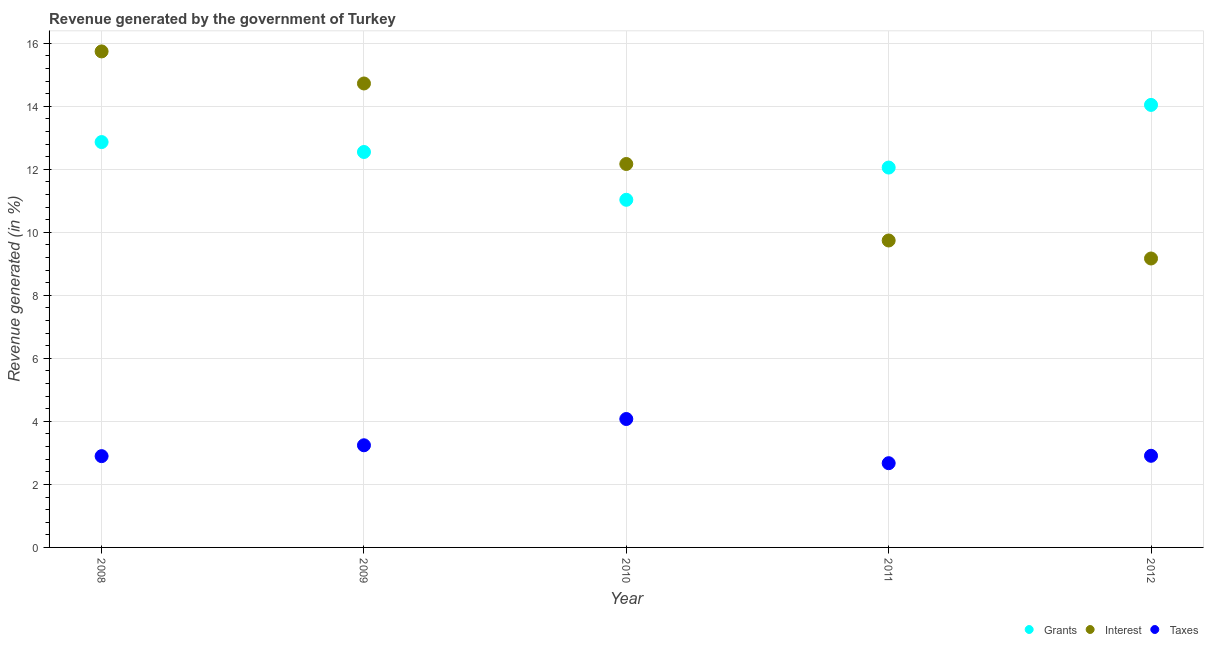How many different coloured dotlines are there?
Your response must be concise. 3. What is the percentage of revenue generated by grants in 2008?
Offer a terse response. 12.86. Across all years, what is the maximum percentage of revenue generated by grants?
Your response must be concise. 14.04. Across all years, what is the minimum percentage of revenue generated by interest?
Your answer should be compact. 9.17. In which year was the percentage of revenue generated by grants maximum?
Provide a succinct answer. 2012. What is the total percentage of revenue generated by taxes in the graph?
Provide a short and direct response. 15.8. What is the difference between the percentage of revenue generated by grants in 2008 and that in 2010?
Offer a very short reply. 1.83. What is the difference between the percentage of revenue generated by taxes in 2010 and the percentage of revenue generated by grants in 2012?
Ensure brevity in your answer.  -9.97. What is the average percentage of revenue generated by grants per year?
Make the answer very short. 12.51. In the year 2008, what is the difference between the percentage of revenue generated by interest and percentage of revenue generated by grants?
Provide a short and direct response. 2.88. What is the ratio of the percentage of revenue generated by taxes in 2009 to that in 2010?
Your answer should be compact. 0.8. What is the difference between the highest and the second highest percentage of revenue generated by taxes?
Give a very brief answer. 0.83. What is the difference between the highest and the lowest percentage of revenue generated by interest?
Your answer should be very brief. 6.57. Is the sum of the percentage of revenue generated by taxes in 2009 and 2011 greater than the maximum percentage of revenue generated by grants across all years?
Give a very brief answer. No. Is it the case that in every year, the sum of the percentage of revenue generated by grants and percentage of revenue generated by interest is greater than the percentage of revenue generated by taxes?
Provide a succinct answer. Yes. Is the percentage of revenue generated by grants strictly less than the percentage of revenue generated by taxes over the years?
Offer a terse response. No. How many years are there in the graph?
Make the answer very short. 5. What is the difference between two consecutive major ticks on the Y-axis?
Provide a short and direct response. 2. Does the graph contain grids?
Offer a terse response. Yes. Where does the legend appear in the graph?
Your answer should be very brief. Bottom right. What is the title of the graph?
Your answer should be very brief. Revenue generated by the government of Turkey. What is the label or title of the Y-axis?
Make the answer very short. Revenue generated (in %). What is the Revenue generated (in %) in Grants in 2008?
Provide a short and direct response. 12.86. What is the Revenue generated (in %) in Interest in 2008?
Your response must be concise. 15.74. What is the Revenue generated (in %) in Taxes in 2008?
Your response must be concise. 2.9. What is the Revenue generated (in %) in Grants in 2009?
Ensure brevity in your answer.  12.55. What is the Revenue generated (in %) in Interest in 2009?
Ensure brevity in your answer.  14.72. What is the Revenue generated (in %) of Taxes in 2009?
Offer a very short reply. 3.24. What is the Revenue generated (in %) in Grants in 2010?
Your answer should be very brief. 11.03. What is the Revenue generated (in %) in Interest in 2010?
Your answer should be very brief. 12.17. What is the Revenue generated (in %) in Taxes in 2010?
Offer a very short reply. 4.08. What is the Revenue generated (in %) in Grants in 2011?
Your answer should be very brief. 12.05. What is the Revenue generated (in %) in Interest in 2011?
Offer a terse response. 9.74. What is the Revenue generated (in %) in Taxes in 2011?
Offer a very short reply. 2.67. What is the Revenue generated (in %) in Grants in 2012?
Provide a succinct answer. 14.04. What is the Revenue generated (in %) of Interest in 2012?
Make the answer very short. 9.17. What is the Revenue generated (in %) of Taxes in 2012?
Keep it short and to the point. 2.91. Across all years, what is the maximum Revenue generated (in %) in Grants?
Make the answer very short. 14.04. Across all years, what is the maximum Revenue generated (in %) of Interest?
Your answer should be compact. 15.74. Across all years, what is the maximum Revenue generated (in %) of Taxes?
Provide a succinct answer. 4.08. Across all years, what is the minimum Revenue generated (in %) in Grants?
Keep it short and to the point. 11.03. Across all years, what is the minimum Revenue generated (in %) in Interest?
Your response must be concise. 9.17. Across all years, what is the minimum Revenue generated (in %) in Taxes?
Offer a terse response. 2.67. What is the total Revenue generated (in %) in Grants in the graph?
Keep it short and to the point. 62.54. What is the total Revenue generated (in %) of Interest in the graph?
Keep it short and to the point. 61.54. What is the total Revenue generated (in %) in Taxes in the graph?
Offer a terse response. 15.8. What is the difference between the Revenue generated (in %) of Grants in 2008 and that in 2009?
Your answer should be very brief. 0.32. What is the difference between the Revenue generated (in %) of Interest in 2008 and that in 2009?
Keep it short and to the point. 1.02. What is the difference between the Revenue generated (in %) in Taxes in 2008 and that in 2009?
Provide a succinct answer. -0.34. What is the difference between the Revenue generated (in %) of Grants in 2008 and that in 2010?
Offer a very short reply. 1.83. What is the difference between the Revenue generated (in %) in Interest in 2008 and that in 2010?
Offer a terse response. 3.57. What is the difference between the Revenue generated (in %) in Taxes in 2008 and that in 2010?
Make the answer very short. -1.18. What is the difference between the Revenue generated (in %) of Grants in 2008 and that in 2011?
Your response must be concise. 0.81. What is the difference between the Revenue generated (in %) in Interest in 2008 and that in 2011?
Provide a short and direct response. 6. What is the difference between the Revenue generated (in %) in Taxes in 2008 and that in 2011?
Your answer should be compact. 0.22. What is the difference between the Revenue generated (in %) of Grants in 2008 and that in 2012?
Keep it short and to the point. -1.18. What is the difference between the Revenue generated (in %) in Interest in 2008 and that in 2012?
Make the answer very short. 6.57. What is the difference between the Revenue generated (in %) in Taxes in 2008 and that in 2012?
Your response must be concise. -0.01. What is the difference between the Revenue generated (in %) in Grants in 2009 and that in 2010?
Your answer should be very brief. 1.52. What is the difference between the Revenue generated (in %) in Interest in 2009 and that in 2010?
Give a very brief answer. 2.56. What is the difference between the Revenue generated (in %) of Taxes in 2009 and that in 2010?
Offer a terse response. -0.83. What is the difference between the Revenue generated (in %) in Grants in 2009 and that in 2011?
Ensure brevity in your answer.  0.49. What is the difference between the Revenue generated (in %) in Interest in 2009 and that in 2011?
Your response must be concise. 4.98. What is the difference between the Revenue generated (in %) of Taxes in 2009 and that in 2011?
Provide a short and direct response. 0.57. What is the difference between the Revenue generated (in %) in Grants in 2009 and that in 2012?
Give a very brief answer. -1.49. What is the difference between the Revenue generated (in %) in Interest in 2009 and that in 2012?
Offer a terse response. 5.55. What is the difference between the Revenue generated (in %) of Taxes in 2009 and that in 2012?
Ensure brevity in your answer.  0.33. What is the difference between the Revenue generated (in %) of Grants in 2010 and that in 2011?
Ensure brevity in your answer.  -1.02. What is the difference between the Revenue generated (in %) in Interest in 2010 and that in 2011?
Give a very brief answer. 2.43. What is the difference between the Revenue generated (in %) in Taxes in 2010 and that in 2011?
Make the answer very short. 1.4. What is the difference between the Revenue generated (in %) in Grants in 2010 and that in 2012?
Keep it short and to the point. -3.01. What is the difference between the Revenue generated (in %) of Interest in 2010 and that in 2012?
Offer a terse response. 3. What is the difference between the Revenue generated (in %) in Taxes in 2010 and that in 2012?
Offer a terse response. 1.17. What is the difference between the Revenue generated (in %) of Grants in 2011 and that in 2012?
Your answer should be very brief. -1.99. What is the difference between the Revenue generated (in %) of Interest in 2011 and that in 2012?
Give a very brief answer. 0.57. What is the difference between the Revenue generated (in %) in Taxes in 2011 and that in 2012?
Provide a short and direct response. -0.23. What is the difference between the Revenue generated (in %) of Grants in 2008 and the Revenue generated (in %) of Interest in 2009?
Provide a succinct answer. -1.86. What is the difference between the Revenue generated (in %) of Grants in 2008 and the Revenue generated (in %) of Taxes in 2009?
Your answer should be very brief. 9.62. What is the difference between the Revenue generated (in %) in Interest in 2008 and the Revenue generated (in %) in Taxes in 2009?
Provide a succinct answer. 12.5. What is the difference between the Revenue generated (in %) in Grants in 2008 and the Revenue generated (in %) in Interest in 2010?
Provide a short and direct response. 0.7. What is the difference between the Revenue generated (in %) in Grants in 2008 and the Revenue generated (in %) in Taxes in 2010?
Keep it short and to the point. 8.79. What is the difference between the Revenue generated (in %) in Interest in 2008 and the Revenue generated (in %) in Taxes in 2010?
Provide a short and direct response. 11.67. What is the difference between the Revenue generated (in %) of Grants in 2008 and the Revenue generated (in %) of Interest in 2011?
Provide a succinct answer. 3.12. What is the difference between the Revenue generated (in %) in Grants in 2008 and the Revenue generated (in %) in Taxes in 2011?
Give a very brief answer. 10.19. What is the difference between the Revenue generated (in %) in Interest in 2008 and the Revenue generated (in %) in Taxes in 2011?
Your answer should be compact. 13.07. What is the difference between the Revenue generated (in %) in Grants in 2008 and the Revenue generated (in %) in Interest in 2012?
Provide a short and direct response. 3.69. What is the difference between the Revenue generated (in %) in Grants in 2008 and the Revenue generated (in %) in Taxes in 2012?
Make the answer very short. 9.96. What is the difference between the Revenue generated (in %) in Interest in 2008 and the Revenue generated (in %) in Taxes in 2012?
Your answer should be very brief. 12.83. What is the difference between the Revenue generated (in %) in Grants in 2009 and the Revenue generated (in %) in Interest in 2010?
Offer a very short reply. 0.38. What is the difference between the Revenue generated (in %) in Grants in 2009 and the Revenue generated (in %) in Taxes in 2010?
Offer a terse response. 8.47. What is the difference between the Revenue generated (in %) of Interest in 2009 and the Revenue generated (in %) of Taxes in 2010?
Offer a very short reply. 10.65. What is the difference between the Revenue generated (in %) of Grants in 2009 and the Revenue generated (in %) of Interest in 2011?
Give a very brief answer. 2.81. What is the difference between the Revenue generated (in %) of Grants in 2009 and the Revenue generated (in %) of Taxes in 2011?
Provide a succinct answer. 9.88. What is the difference between the Revenue generated (in %) in Interest in 2009 and the Revenue generated (in %) in Taxes in 2011?
Ensure brevity in your answer.  12.05. What is the difference between the Revenue generated (in %) in Grants in 2009 and the Revenue generated (in %) in Interest in 2012?
Offer a terse response. 3.38. What is the difference between the Revenue generated (in %) of Grants in 2009 and the Revenue generated (in %) of Taxes in 2012?
Give a very brief answer. 9.64. What is the difference between the Revenue generated (in %) of Interest in 2009 and the Revenue generated (in %) of Taxes in 2012?
Offer a terse response. 11.82. What is the difference between the Revenue generated (in %) of Grants in 2010 and the Revenue generated (in %) of Interest in 2011?
Your answer should be very brief. 1.29. What is the difference between the Revenue generated (in %) of Grants in 2010 and the Revenue generated (in %) of Taxes in 2011?
Offer a terse response. 8.36. What is the difference between the Revenue generated (in %) of Interest in 2010 and the Revenue generated (in %) of Taxes in 2011?
Give a very brief answer. 9.5. What is the difference between the Revenue generated (in %) in Grants in 2010 and the Revenue generated (in %) in Interest in 2012?
Offer a terse response. 1.86. What is the difference between the Revenue generated (in %) of Grants in 2010 and the Revenue generated (in %) of Taxes in 2012?
Your response must be concise. 8.12. What is the difference between the Revenue generated (in %) in Interest in 2010 and the Revenue generated (in %) in Taxes in 2012?
Keep it short and to the point. 9.26. What is the difference between the Revenue generated (in %) of Grants in 2011 and the Revenue generated (in %) of Interest in 2012?
Your answer should be very brief. 2.89. What is the difference between the Revenue generated (in %) in Grants in 2011 and the Revenue generated (in %) in Taxes in 2012?
Your answer should be compact. 9.15. What is the difference between the Revenue generated (in %) in Interest in 2011 and the Revenue generated (in %) in Taxes in 2012?
Keep it short and to the point. 6.83. What is the average Revenue generated (in %) of Grants per year?
Your response must be concise. 12.51. What is the average Revenue generated (in %) in Interest per year?
Provide a succinct answer. 12.31. What is the average Revenue generated (in %) of Taxes per year?
Your response must be concise. 3.16. In the year 2008, what is the difference between the Revenue generated (in %) of Grants and Revenue generated (in %) of Interest?
Offer a terse response. -2.88. In the year 2008, what is the difference between the Revenue generated (in %) of Grants and Revenue generated (in %) of Taxes?
Your answer should be compact. 9.97. In the year 2008, what is the difference between the Revenue generated (in %) in Interest and Revenue generated (in %) in Taxes?
Give a very brief answer. 12.84. In the year 2009, what is the difference between the Revenue generated (in %) in Grants and Revenue generated (in %) in Interest?
Provide a short and direct response. -2.17. In the year 2009, what is the difference between the Revenue generated (in %) of Grants and Revenue generated (in %) of Taxes?
Your response must be concise. 9.31. In the year 2009, what is the difference between the Revenue generated (in %) of Interest and Revenue generated (in %) of Taxes?
Provide a succinct answer. 11.48. In the year 2010, what is the difference between the Revenue generated (in %) in Grants and Revenue generated (in %) in Interest?
Your response must be concise. -1.14. In the year 2010, what is the difference between the Revenue generated (in %) in Grants and Revenue generated (in %) in Taxes?
Your answer should be very brief. 6.96. In the year 2010, what is the difference between the Revenue generated (in %) in Interest and Revenue generated (in %) in Taxes?
Provide a succinct answer. 8.09. In the year 2011, what is the difference between the Revenue generated (in %) in Grants and Revenue generated (in %) in Interest?
Keep it short and to the point. 2.31. In the year 2011, what is the difference between the Revenue generated (in %) in Grants and Revenue generated (in %) in Taxes?
Offer a very short reply. 9.38. In the year 2011, what is the difference between the Revenue generated (in %) of Interest and Revenue generated (in %) of Taxes?
Provide a short and direct response. 7.07. In the year 2012, what is the difference between the Revenue generated (in %) in Grants and Revenue generated (in %) in Interest?
Give a very brief answer. 4.87. In the year 2012, what is the difference between the Revenue generated (in %) in Grants and Revenue generated (in %) in Taxes?
Provide a succinct answer. 11.14. In the year 2012, what is the difference between the Revenue generated (in %) in Interest and Revenue generated (in %) in Taxes?
Make the answer very short. 6.26. What is the ratio of the Revenue generated (in %) of Grants in 2008 to that in 2009?
Ensure brevity in your answer.  1.03. What is the ratio of the Revenue generated (in %) of Interest in 2008 to that in 2009?
Ensure brevity in your answer.  1.07. What is the ratio of the Revenue generated (in %) in Taxes in 2008 to that in 2009?
Offer a very short reply. 0.89. What is the ratio of the Revenue generated (in %) in Grants in 2008 to that in 2010?
Offer a terse response. 1.17. What is the ratio of the Revenue generated (in %) in Interest in 2008 to that in 2010?
Your response must be concise. 1.29. What is the ratio of the Revenue generated (in %) of Taxes in 2008 to that in 2010?
Give a very brief answer. 0.71. What is the ratio of the Revenue generated (in %) in Grants in 2008 to that in 2011?
Offer a terse response. 1.07. What is the ratio of the Revenue generated (in %) of Interest in 2008 to that in 2011?
Make the answer very short. 1.62. What is the ratio of the Revenue generated (in %) in Taxes in 2008 to that in 2011?
Offer a very short reply. 1.08. What is the ratio of the Revenue generated (in %) of Grants in 2008 to that in 2012?
Your response must be concise. 0.92. What is the ratio of the Revenue generated (in %) in Interest in 2008 to that in 2012?
Make the answer very short. 1.72. What is the ratio of the Revenue generated (in %) of Grants in 2009 to that in 2010?
Provide a succinct answer. 1.14. What is the ratio of the Revenue generated (in %) in Interest in 2009 to that in 2010?
Keep it short and to the point. 1.21. What is the ratio of the Revenue generated (in %) in Taxes in 2009 to that in 2010?
Offer a terse response. 0.8. What is the ratio of the Revenue generated (in %) of Grants in 2009 to that in 2011?
Make the answer very short. 1.04. What is the ratio of the Revenue generated (in %) of Interest in 2009 to that in 2011?
Offer a terse response. 1.51. What is the ratio of the Revenue generated (in %) of Taxes in 2009 to that in 2011?
Your answer should be very brief. 1.21. What is the ratio of the Revenue generated (in %) in Grants in 2009 to that in 2012?
Ensure brevity in your answer.  0.89. What is the ratio of the Revenue generated (in %) of Interest in 2009 to that in 2012?
Offer a terse response. 1.61. What is the ratio of the Revenue generated (in %) of Taxes in 2009 to that in 2012?
Provide a succinct answer. 1.11. What is the ratio of the Revenue generated (in %) of Grants in 2010 to that in 2011?
Your response must be concise. 0.92. What is the ratio of the Revenue generated (in %) of Interest in 2010 to that in 2011?
Offer a very short reply. 1.25. What is the ratio of the Revenue generated (in %) of Taxes in 2010 to that in 2011?
Give a very brief answer. 1.52. What is the ratio of the Revenue generated (in %) in Grants in 2010 to that in 2012?
Offer a very short reply. 0.79. What is the ratio of the Revenue generated (in %) in Interest in 2010 to that in 2012?
Give a very brief answer. 1.33. What is the ratio of the Revenue generated (in %) of Taxes in 2010 to that in 2012?
Give a very brief answer. 1.4. What is the ratio of the Revenue generated (in %) in Grants in 2011 to that in 2012?
Provide a short and direct response. 0.86. What is the ratio of the Revenue generated (in %) of Interest in 2011 to that in 2012?
Offer a very short reply. 1.06. What is the ratio of the Revenue generated (in %) of Taxes in 2011 to that in 2012?
Your answer should be compact. 0.92. What is the difference between the highest and the second highest Revenue generated (in %) in Grants?
Your response must be concise. 1.18. What is the difference between the highest and the second highest Revenue generated (in %) in Interest?
Your response must be concise. 1.02. What is the difference between the highest and the second highest Revenue generated (in %) in Taxes?
Your response must be concise. 0.83. What is the difference between the highest and the lowest Revenue generated (in %) of Grants?
Your answer should be very brief. 3.01. What is the difference between the highest and the lowest Revenue generated (in %) in Interest?
Your response must be concise. 6.57. What is the difference between the highest and the lowest Revenue generated (in %) in Taxes?
Your answer should be very brief. 1.4. 